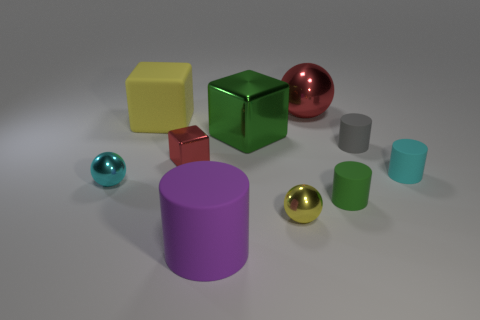What number of big metal objects have the same color as the small metallic cube?
Ensure brevity in your answer.  1. Is there a small cyan thing that has the same shape as the big yellow thing?
Provide a succinct answer. No. Does the metal thing that is behind the large matte block have the same size as the cylinder on the right side of the gray thing?
Keep it short and to the point. No. Are there fewer tiny cyan balls right of the purple object than red things that are in front of the small gray thing?
Offer a terse response. Yes. What material is the big object that is the same color as the tiny cube?
Keep it short and to the point. Metal. There is a small matte thing to the right of the gray object; what color is it?
Keep it short and to the point. Cyan. Do the big matte cylinder and the large matte block have the same color?
Keep it short and to the point. No. What number of big spheres are behind the yellow object behind the green thing that is to the left of the big red metal ball?
Provide a short and direct response. 1. The purple object is what size?
Offer a very short reply. Large. What material is the cylinder that is the same size as the red metallic ball?
Offer a terse response. Rubber. 